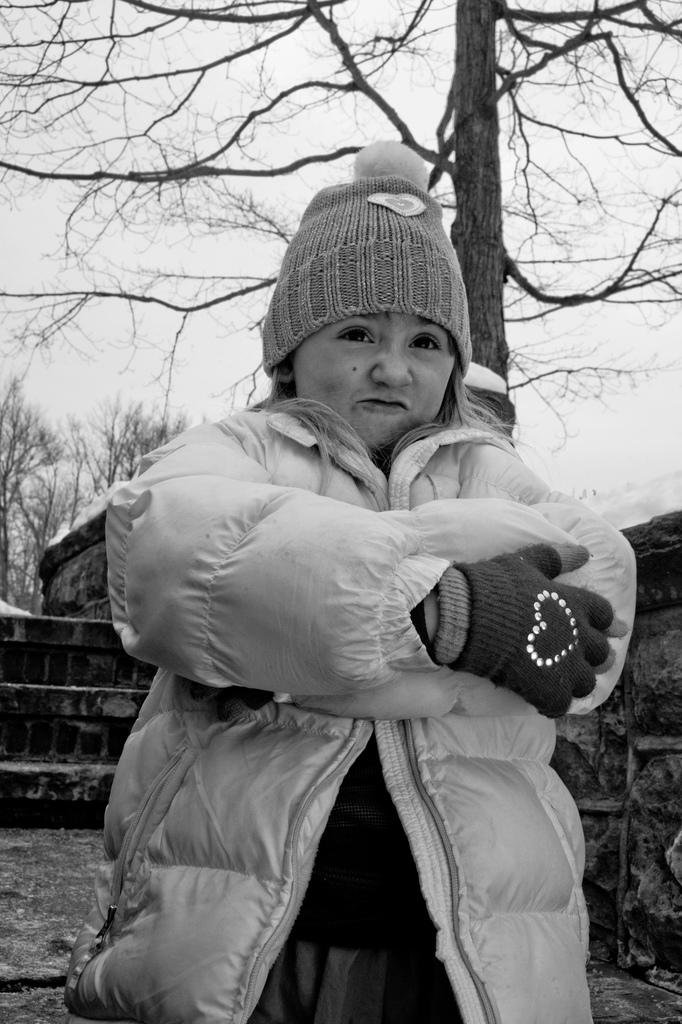What is the person in the image wearing? The person in the image is wearing a jacket and cap. What can be seen in the background of the image? There is a wall, many trees, and the sky visible in the background of the image. What is the color scheme of the image? The image is black and white. What type of meat is being prepared on the farm in the image? There is no farm or meat present in the image; it is a black and white image of a person wearing a jacket and cap with a wall, trees, and sky in the background. What type of lace can be seen on the person's clothing in the image? There is no lace visible on the person's clothing in the image; they are wearing a jacket and cap. 